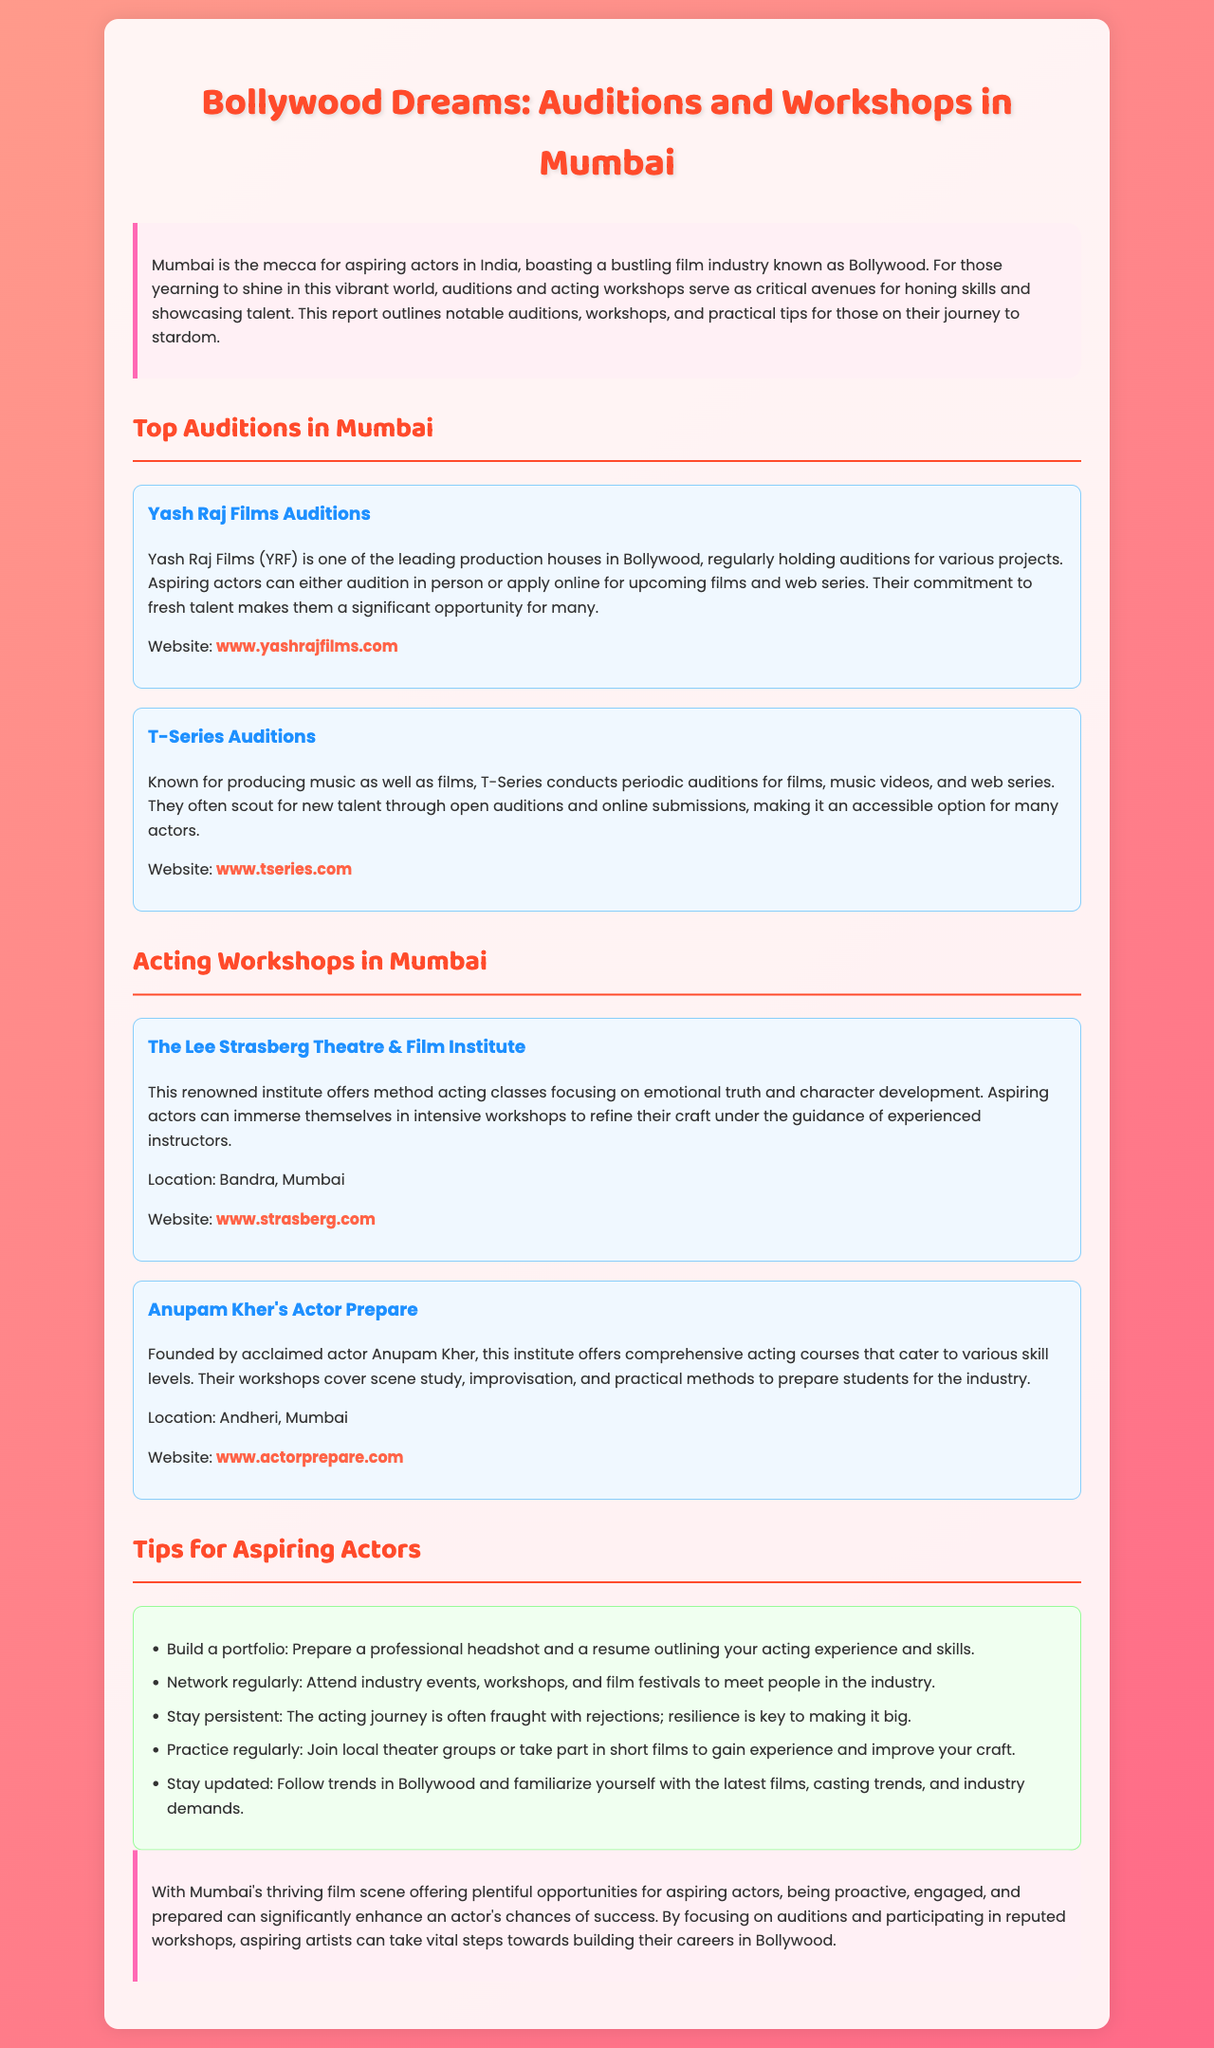What is the title of the report? The title of the report is mentioned prominently at the top of the document.
Answer: Bollywood Dreams: Auditions and Workshops in Mumbai Which production house regularly holds auditions for various projects? The document highlights Yash Raj Films as a leading production house that regularly holds auditions.
Answer: Yash Raj Films What kind of classes does The Lee Strasberg Theatre & Film Institute offer? The document states that this institute offers method acting classes focusing on emotional truth and character development.
Answer: Method acting classes Where is Anupam Kher's Actor Prepare located? The document specifies the location of Anupam Kher's Actor Prepare in Andheri, Mumbai.
Answer: Andheri, Mumbai Name one tip for aspiring actors mentioned in the document. The document lists several tips, including building a portfolio, which is a key suggestion for aspiring actors.
Answer: Build a portfolio Why is networking important for aspiring actors? The document indicates that networking helps actors meet people in the industry and may provide opportunities.
Answer: Meet people in the industry What type of auditions does T-Series conduct? The report notes that T-Series conducts auditions for films, music videos, and web series.
Answer: Films, music videos, and web series What is a common challenge faced by aspiring actors according to the report? The document mentions that rejections are a common challenge in the acting journey, indicating the need for resilience.
Answer: Rejections How can aspiring actors stay updated according to the report? The document suggests that following trends in Bollywood can help aspiring actors stay updated.
Answer: Follow trends in Bollywood 